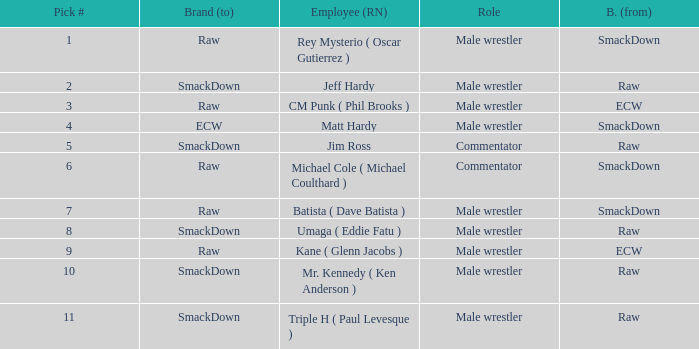Would you be able to parse every entry in this table? {'header': ['Pick #', 'Brand (to)', 'Employee (RN)', 'Role', 'B. (from)'], 'rows': [['1', 'Raw', 'Rey Mysterio ( Oscar Gutierrez )', 'Male wrestler', 'SmackDown'], ['2', 'SmackDown', 'Jeff Hardy', 'Male wrestler', 'Raw'], ['3', 'Raw', 'CM Punk ( Phil Brooks )', 'Male wrestler', 'ECW'], ['4', 'ECW', 'Matt Hardy', 'Male wrestler', 'SmackDown'], ['5', 'SmackDown', 'Jim Ross', 'Commentator', 'Raw'], ['6', 'Raw', 'Michael Cole ( Michael Coulthard )', 'Commentator', 'SmackDown'], ['7', 'Raw', 'Batista ( Dave Batista )', 'Male wrestler', 'SmackDown'], ['8', 'SmackDown', 'Umaga ( Eddie Fatu )', 'Male wrestler', 'Raw'], ['9', 'Raw', 'Kane ( Glenn Jacobs )', 'Male wrestler', 'ECW'], ['10', 'SmackDown', 'Mr. Kennedy ( Ken Anderson )', 'Male wrestler', 'Raw'], ['11', 'SmackDown', 'Triple H ( Paul Levesque )', 'Male wrestler', 'Raw']]} What is the actual name of the male wrestler on raw with a selection number less than 6? Jeff Hardy. 